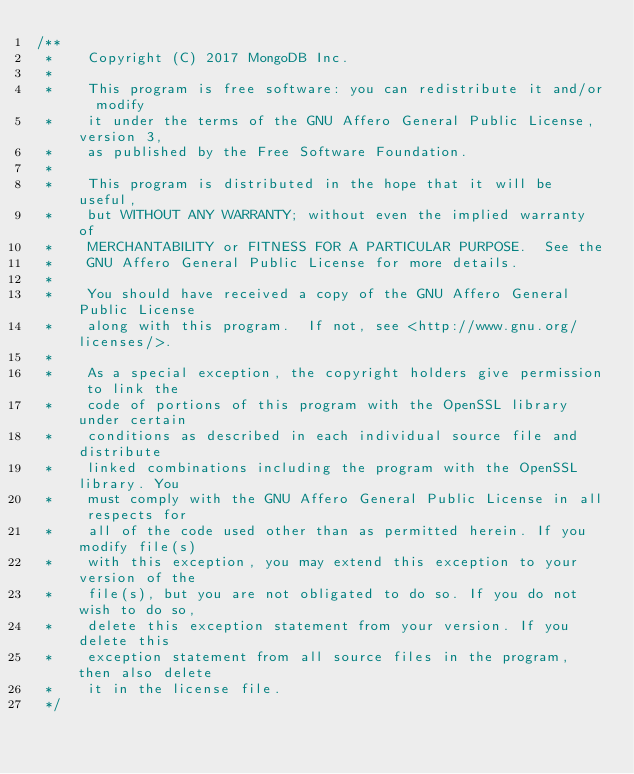<code> <loc_0><loc_0><loc_500><loc_500><_C_>/**
 *    Copyright (C) 2017 MongoDB Inc.
 *
 *    This program is free software: you can redistribute it and/or  modify
 *    it under the terms of the GNU Affero General Public License, version 3,
 *    as published by the Free Software Foundation.
 *
 *    This program is distributed in the hope that it will be useful,
 *    but WITHOUT ANY WARRANTY; without even the implied warranty of
 *    MERCHANTABILITY or FITNESS FOR A PARTICULAR PURPOSE.  See the
 *    GNU Affero General Public License for more details.
 *
 *    You should have received a copy of the GNU Affero General Public License
 *    along with this program.  If not, see <http://www.gnu.org/licenses/>.
 *
 *    As a special exception, the copyright holders give permission to link the
 *    code of portions of this program with the OpenSSL library under certain
 *    conditions as described in each individual source file and distribute
 *    linked combinations including the program with the OpenSSL library. You
 *    must comply with the GNU Affero General Public License in all respects for
 *    all of the code used other than as permitted herein. If you modify file(s)
 *    with this exception, you may extend this exception to your version of the
 *    file(s), but you are not obligated to do so. If you do not wish to do so,
 *    delete this exception statement from your version. If you delete this
 *    exception statement from all source files in the program, then also delete
 *    it in the license file.
 */
</code> 